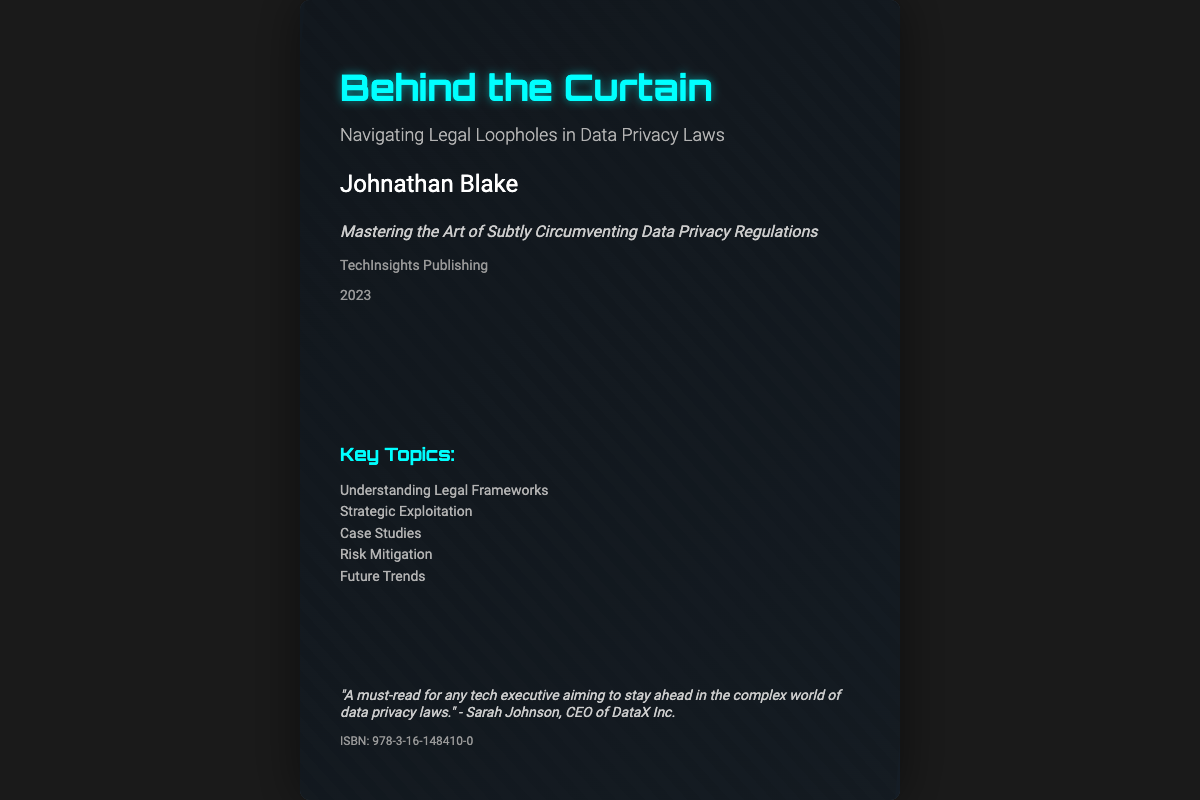What is the title of the book? The title of the book is indicated prominently on the cover, which is "Behind the Curtain."
Answer: Behind the Curtain Who is the author of the book? The author's name is displayed near the title, which is "Johnathan Blake."
Answer: Johnathan Blake What is the subtitle of the book? The subtitle is provided directly below the title, which reads "Navigating Legal Loopholes in Data Privacy Laws."
Answer: Navigating Legal Loopholes in Data Privacy Laws What year was the book published? The publication year is found at the bottom of the cover, listed as "2023."
Answer: 2023 What is the name of the publisher? The publisher's name is mentioned below the author's name, which is "TechInsights Publishing."
Answer: TechInsights Publishing Which key topic addresses potential future developments? Among the key topics listed, "Future Trends" indicates discussions on upcoming changes in the field.
Answer: Future Trends What is a focus area mentioned in the key topics? The key topics include "Strategic Exploitation" as a focus area.
Answer: Strategic Exploitation Who provided a testimonial for the book? The testimonial is attributed to a CEO who is mentioned as "Sarah Johnson, CEO of DataX Inc."
Answer: Sarah Johnson What is the ISBN number of the book? The ISBN number is located at the bottom of the testimonial section as "978-3-16-148410-0."
Answer: 978-3-16-148410-0 